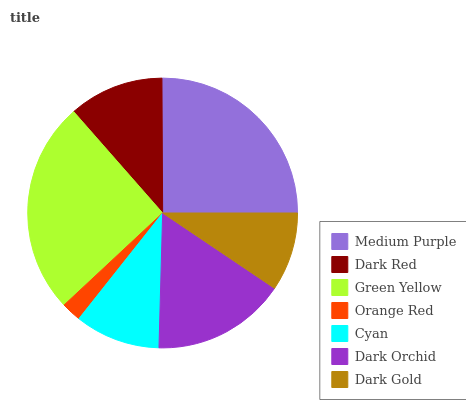Is Orange Red the minimum?
Answer yes or no. Yes. Is Green Yellow the maximum?
Answer yes or no. Yes. Is Dark Red the minimum?
Answer yes or no. No. Is Dark Red the maximum?
Answer yes or no. No. Is Medium Purple greater than Dark Red?
Answer yes or no. Yes. Is Dark Red less than Medium Purple?
Answer yes or no. Yes. Is Dark Red greater than Medium Purple?
Answer yes or no. No. Is Medium Purple less than Dark Red?
Answer yes or no. No. Is Dark Red the high median?
Answer yes or no. Yes. Is Dark Red the low median?
Answer yes or no. Yes. Is Medium Purple the high median?
Answer yes or no. No. Is Green Yellow the low median?
Answer yes or no. No. 